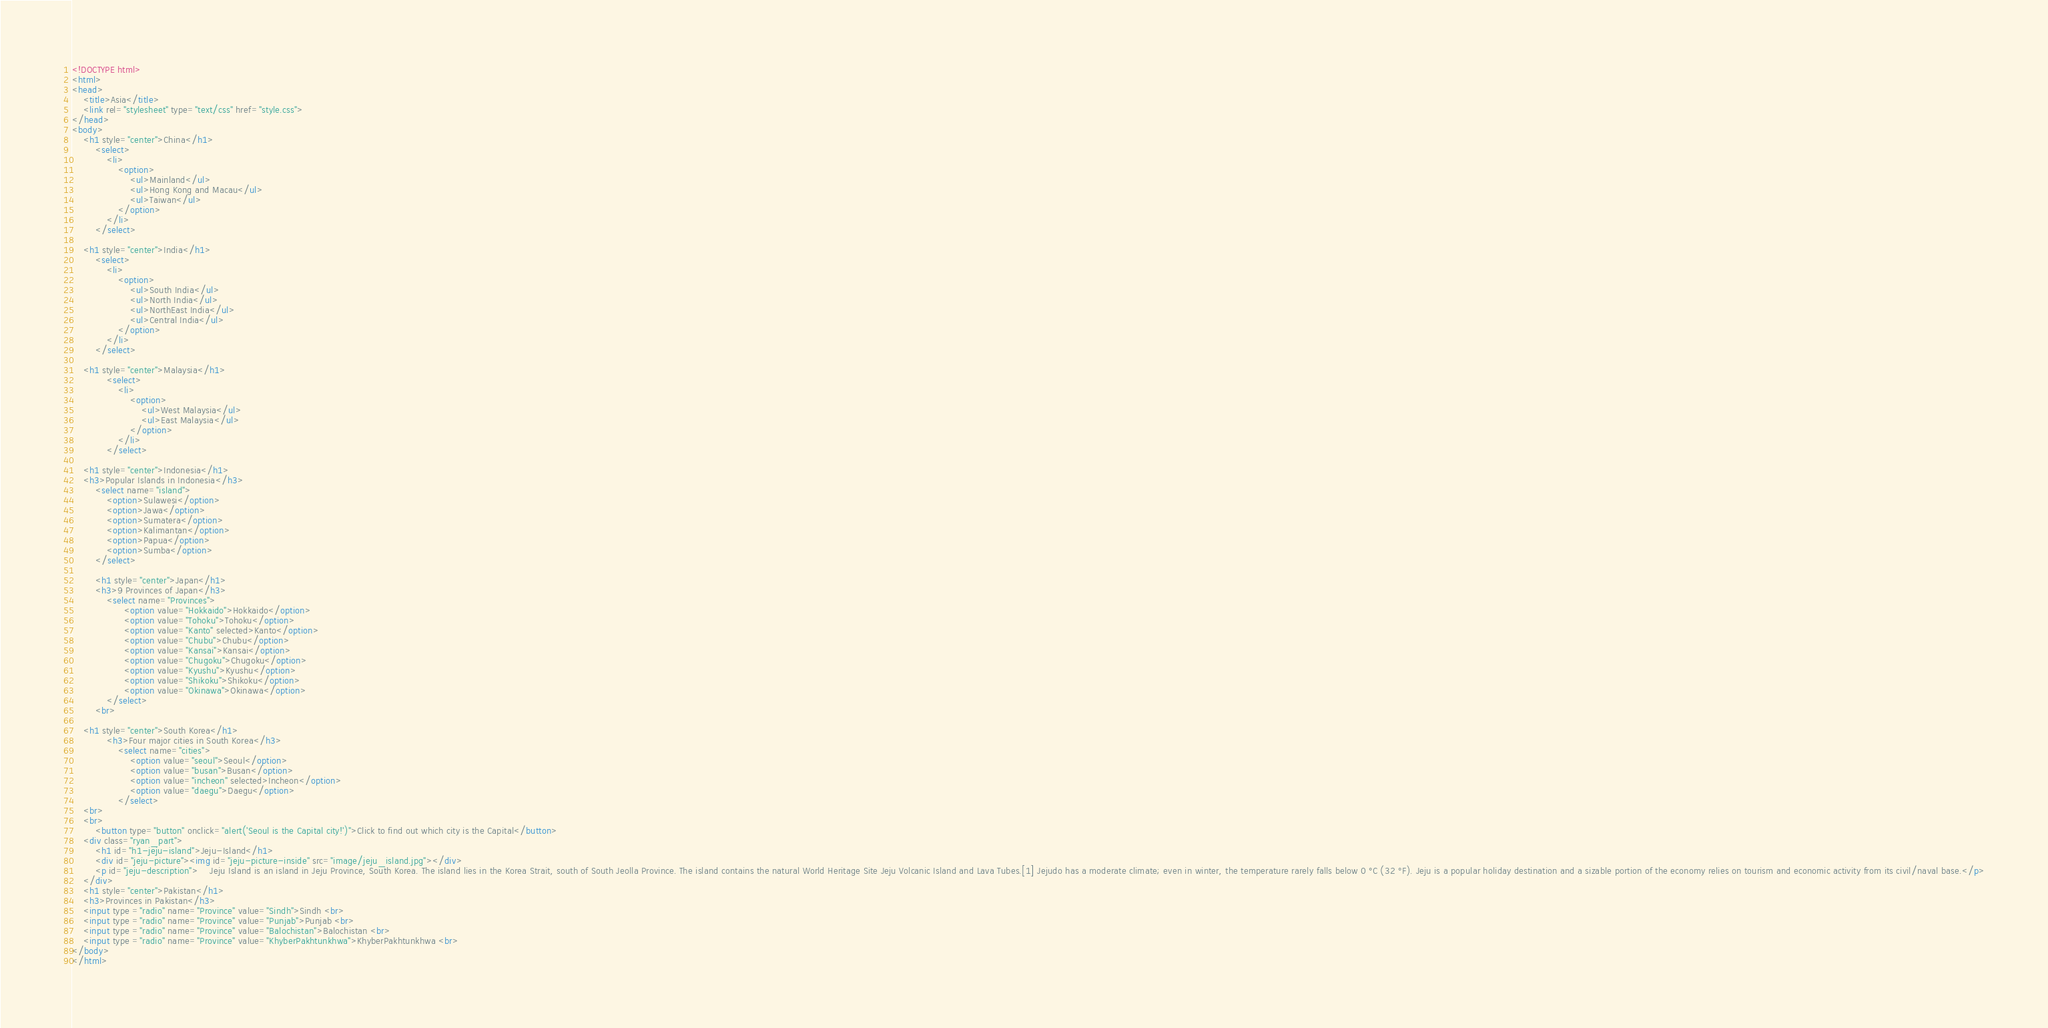Convert code to text. <code><loc_0><loc_0><loc_500><loc_500><_HTML_><!DOCTYPE html>
<html>
<head>
	<title>Asia</title>
	<link rel="stylesheet" type="text/css" href="style.css">
</head>
<body>
	<h1 style="center">China</h1>
		<select>
			<li>
				<option>
					<ul>Mainland</ul>
					<ul>Hong Kong and Macau</ul>
					<ul>Taiwan</ul>
				</option>
			</li>
		</select>

	<h1 style="center">India</h1>
		<select>
			<li>
				<option>
					<ul>South India</ul>
					<ul>North India</ul>
					<ul>NorthEast India</ul>
					<ul>Central India</ul>
				</option>
			</li>
		</select>

	<h1 style="center">Malaysia</h1>
        	<select>
       			<li>
             		<option>
                		<ul>West Malaysia</ul>
                		<ul>East Malaysia</ul>
            		</option>
        		</li>
        	</select>

	<h1 style="center">Indonesia</h1>
	<h3>Popular Islands in Indonesia</h3>
		<select name="island">
			<option>Sulawesi</option>
			<option>Jawa</option>
			<option>Sumatera</option>
			<option>Kalimantan</option>
			<option>Papua</option>
			<option>Sumba</option>
		</select>

		<h1 style="center">Japan</h1>
		<h3>9 Provinces of Japan</h3>
			<select name="Provinces">
				  <option value="Hokkaido">Hokkaido</option>
				  <option value="Tohoku">Tohoku</option>
				  <option value="Kanto" selected>Kanto</option>
				  <option value="Chubu">Chubu</option>
				  <option value="Kansai">Kansai</option>
				  <option value="Chugoku">Chugoku</option>
				  <option value="Kyushu">Kyushu</option>
				  <option value="Shikoku">Shikoku</option>
				  <option value="Okinawa">Okinawa</option>
			</select>
		<br>	

	<h1 style="center">South Korea</h1>
    		<h3>Four major cities in South Korea</h3>
	    		<select name="cities">
		  			<option value="seoul">Seoul</option>
		  			<option value="busan">Busan</option>
		  			<option value="incheon" selected>Incheon</option>
		  			<option value="daegu">Daegu</option>
				</select>
	<br>
	<br>
		<button type="button" onclick="alert('Seoul is the Capital city!')">Click to find out which city is the Capital</button>
	<div class="ryan_part">	
		<h1 id="h1-jeju-island">Jeju-Island</h1>
		<div id="jeju-picture"><img id="jeju-picture-inside" src="image/jeju_island.jpg"></div>
		<p id="jeju-description">	Jeju Island is an island in Jeju Province, South Korea. The island lies in the Korea Strait, south of South Jeolla Province. The island contains the natural World Heritage Site Jeju Volcanic Island and Lava Tubes.[1] Jejudo has a moderate climate; even in winter, the temperature rarely falls below 0 °C (32 °F). Jeju is a popular holiday destination and a sizable portion of the economy relies on tourism and economic activity from its civil/naval base.</p>
	</div>	
	<h1 style="center">Pakistan</h1>
	<h3>Provinces in Pakistan</h3>
	<input type ="radio" name="Province" value="Sindh">Sindh <br>
	<input type ="radio" name="Province" value="Punjab">Punjab <br>
	<input type ="radio" name="Province" value="Balochistan">Balochistan <br>
	<input type ="radio" name="Province" value="KhyberPakhtunkhwa">KhyberPakhtunkhwa <br>
</body>
</html>
</code> 